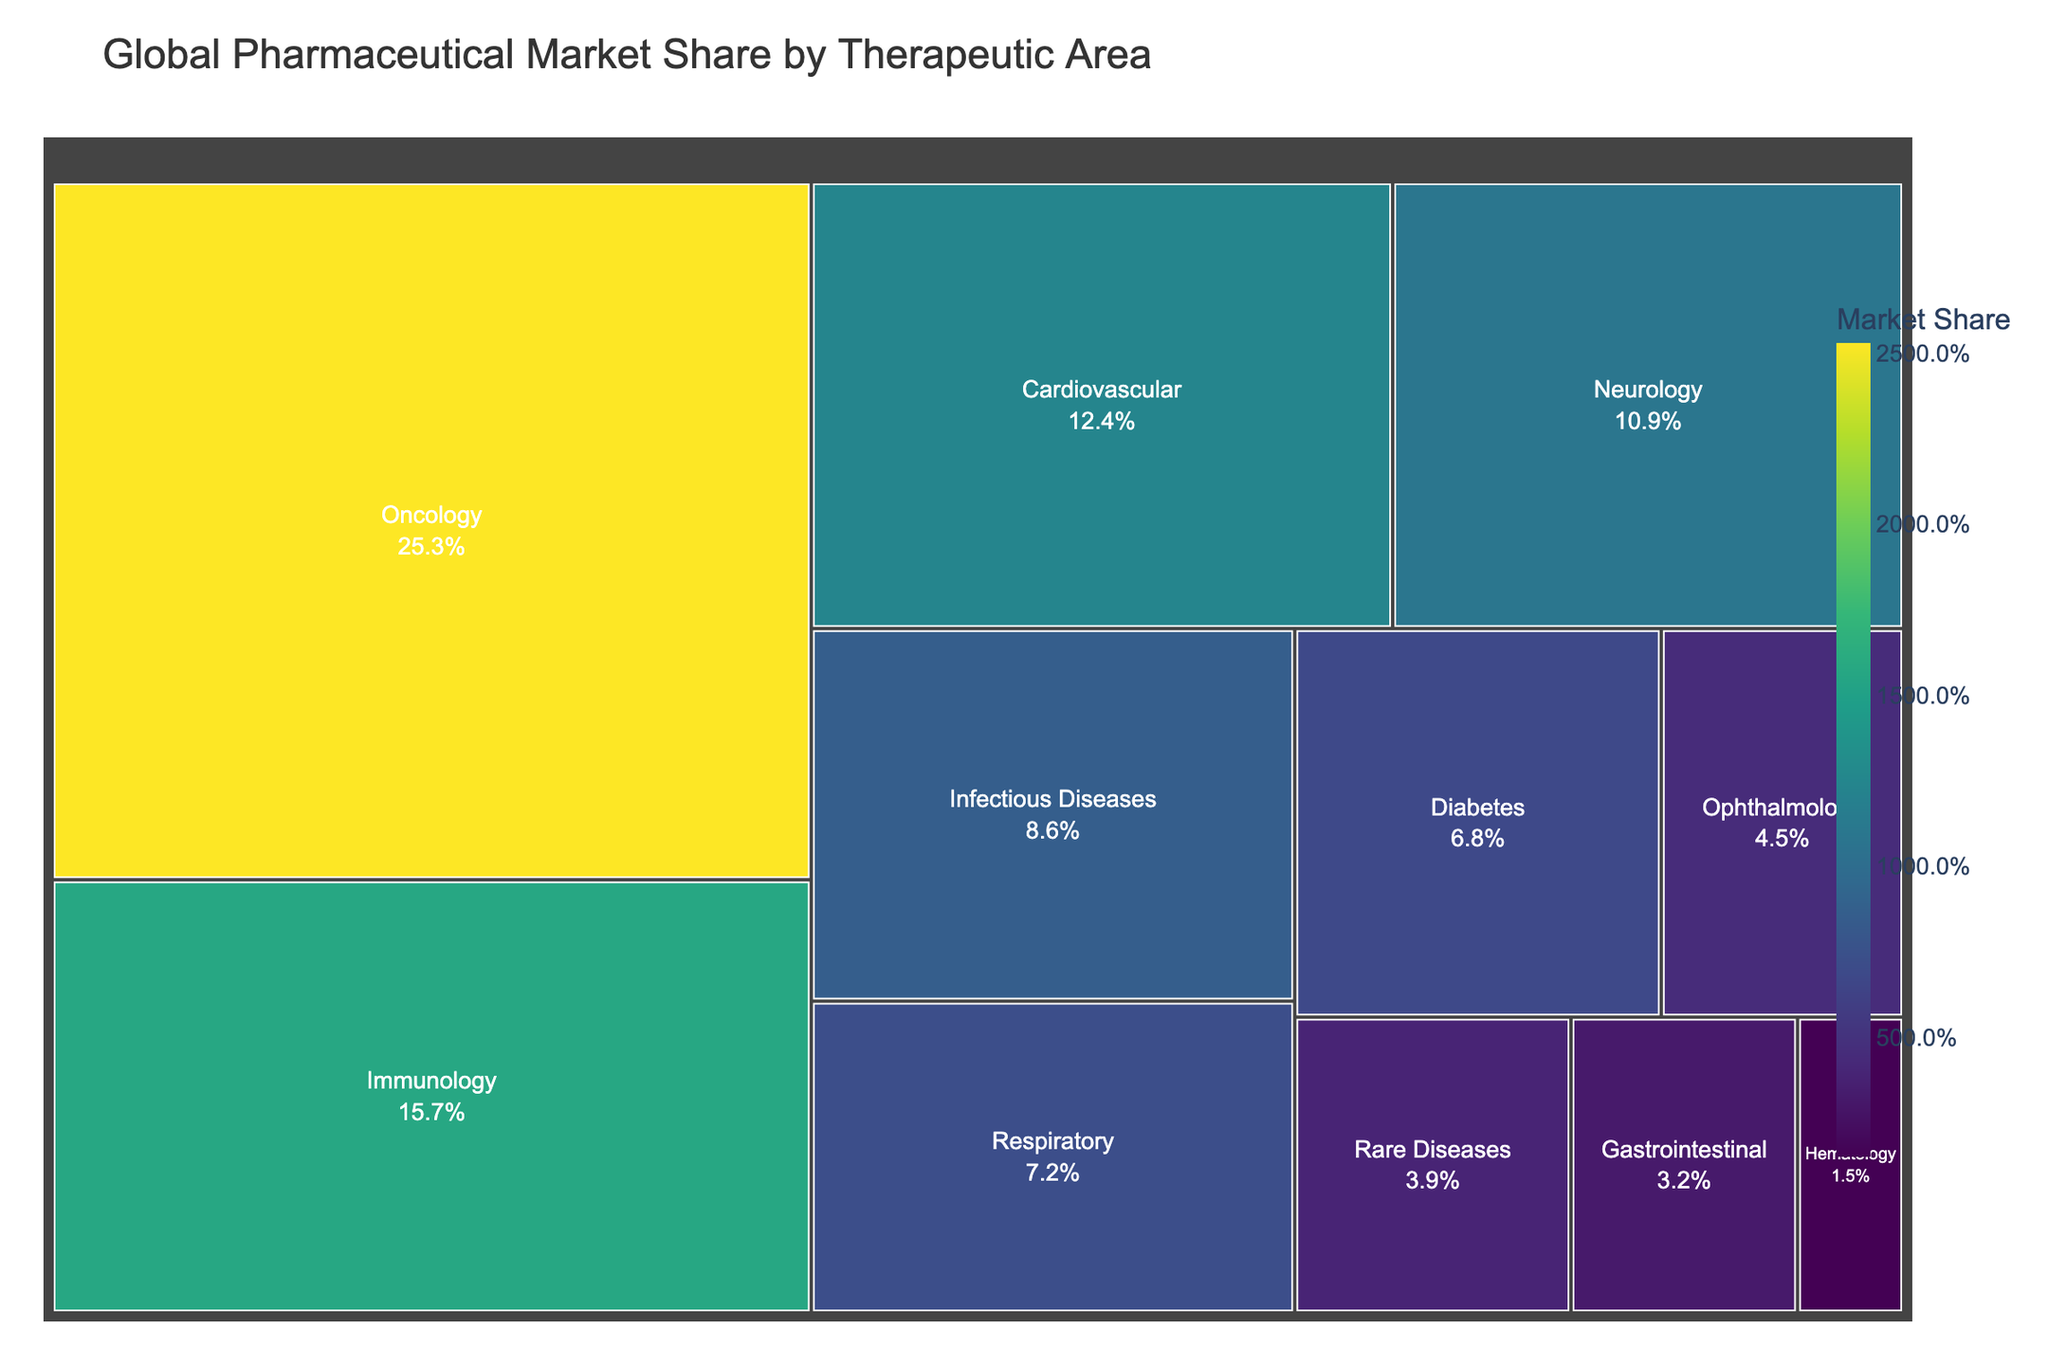What is the title of the treemap? The title is usually presented at the top of the chart and describes its content.
Answer: Global Pharmaceutical Market Share by Therapeutic Area How many therapeutic areas are represented in the treemap? Count the number of distinct blocks or labels representing different therapeutic areas.
Answer: 11 Which therapeutic area has the highest market share? Identify the biggest block or the one with the highest percentage labeled on the treemap.
Answer: Oncology What is the market share of Immunology? Find the block labeled "Immunology" and read the market share percentage.
Answer: 15.7% What's the total market share of the Gastrointestinal and Hematology therapeutic areas? Add the market shares of both therapeutic areas: Gastrointestinal (3.2%) and Hematology (1.5%). 3.2 + 1.5 = 4.7%
Answer: 4.7% Which therapeutic area has a larger market share: Neurology or Respiratory? Compare the market share percentages labeled on the Neurology and Respiratory blocks: Neurology (10.9%) vs. Respiratory (7.2%).
Answer: Neurology What is the difference in market share between Oncology and Diabetes? Subtract the market share of Diabetes from the market share of Oncology: 25.3% - 6.8% = 18.5%
Answer: 18.5% What fraction of the market share is held by Cardiovascular compared to the total market share of Rare Diseases and Ophthalmology? Calculate the sum of the market share of Rare Diseases and Ophthalmology: 3.9% + 4.5% = 8.4%. Then divide the market share of Cardiovascular by this sum: 12.4% / 8.4% ≈ 1.48
Answer: 1.48 Which therapeutic area occupies the smallest block in the treemap? Identify the block with the smallest size or the lowest market share percentage labeled.
Answer: Hematology What is the cumulative market share of the top three therapeutic areas? Add the market shares of the top three therapeutic areas: Oncology (25.3%), Immunology (15.7%), and Cardiovascular (12.4%). 25.3 + 15.7 + 12.4 = 53.4%
Answer: 53.4% 